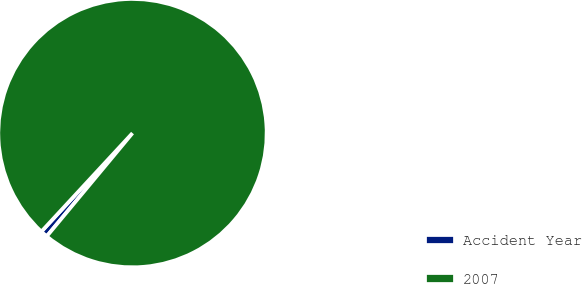Convert chart. <chart><loc_0><loc_0><loc_500><loc_500><pie_chart><fcel>Accident Year<fcel>2007<nl><fcel>0.85%<fcel>99.15%<nl></chart> 